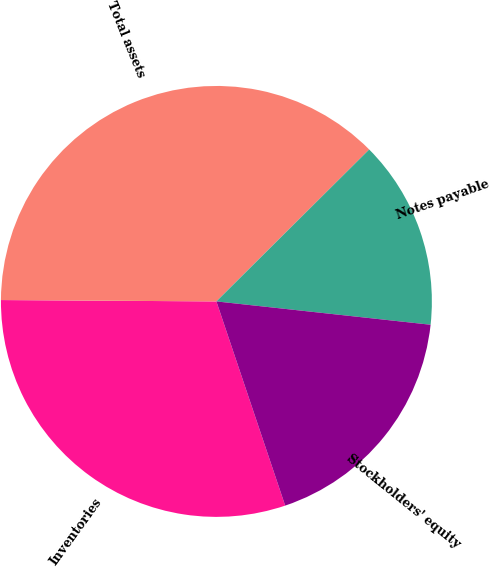Convert chart to OTSL. <chart><loc_0><loc_0><loc_500><loc_500><pie_chart><fcel>Inventories<fcel>Total assets<fcel>Notes payable<fcel>Stockholders' equity<nl><fcel>30.27%<fcel>37.44%<fcel>14.18%<fcel>18.1%<nl></chart> 